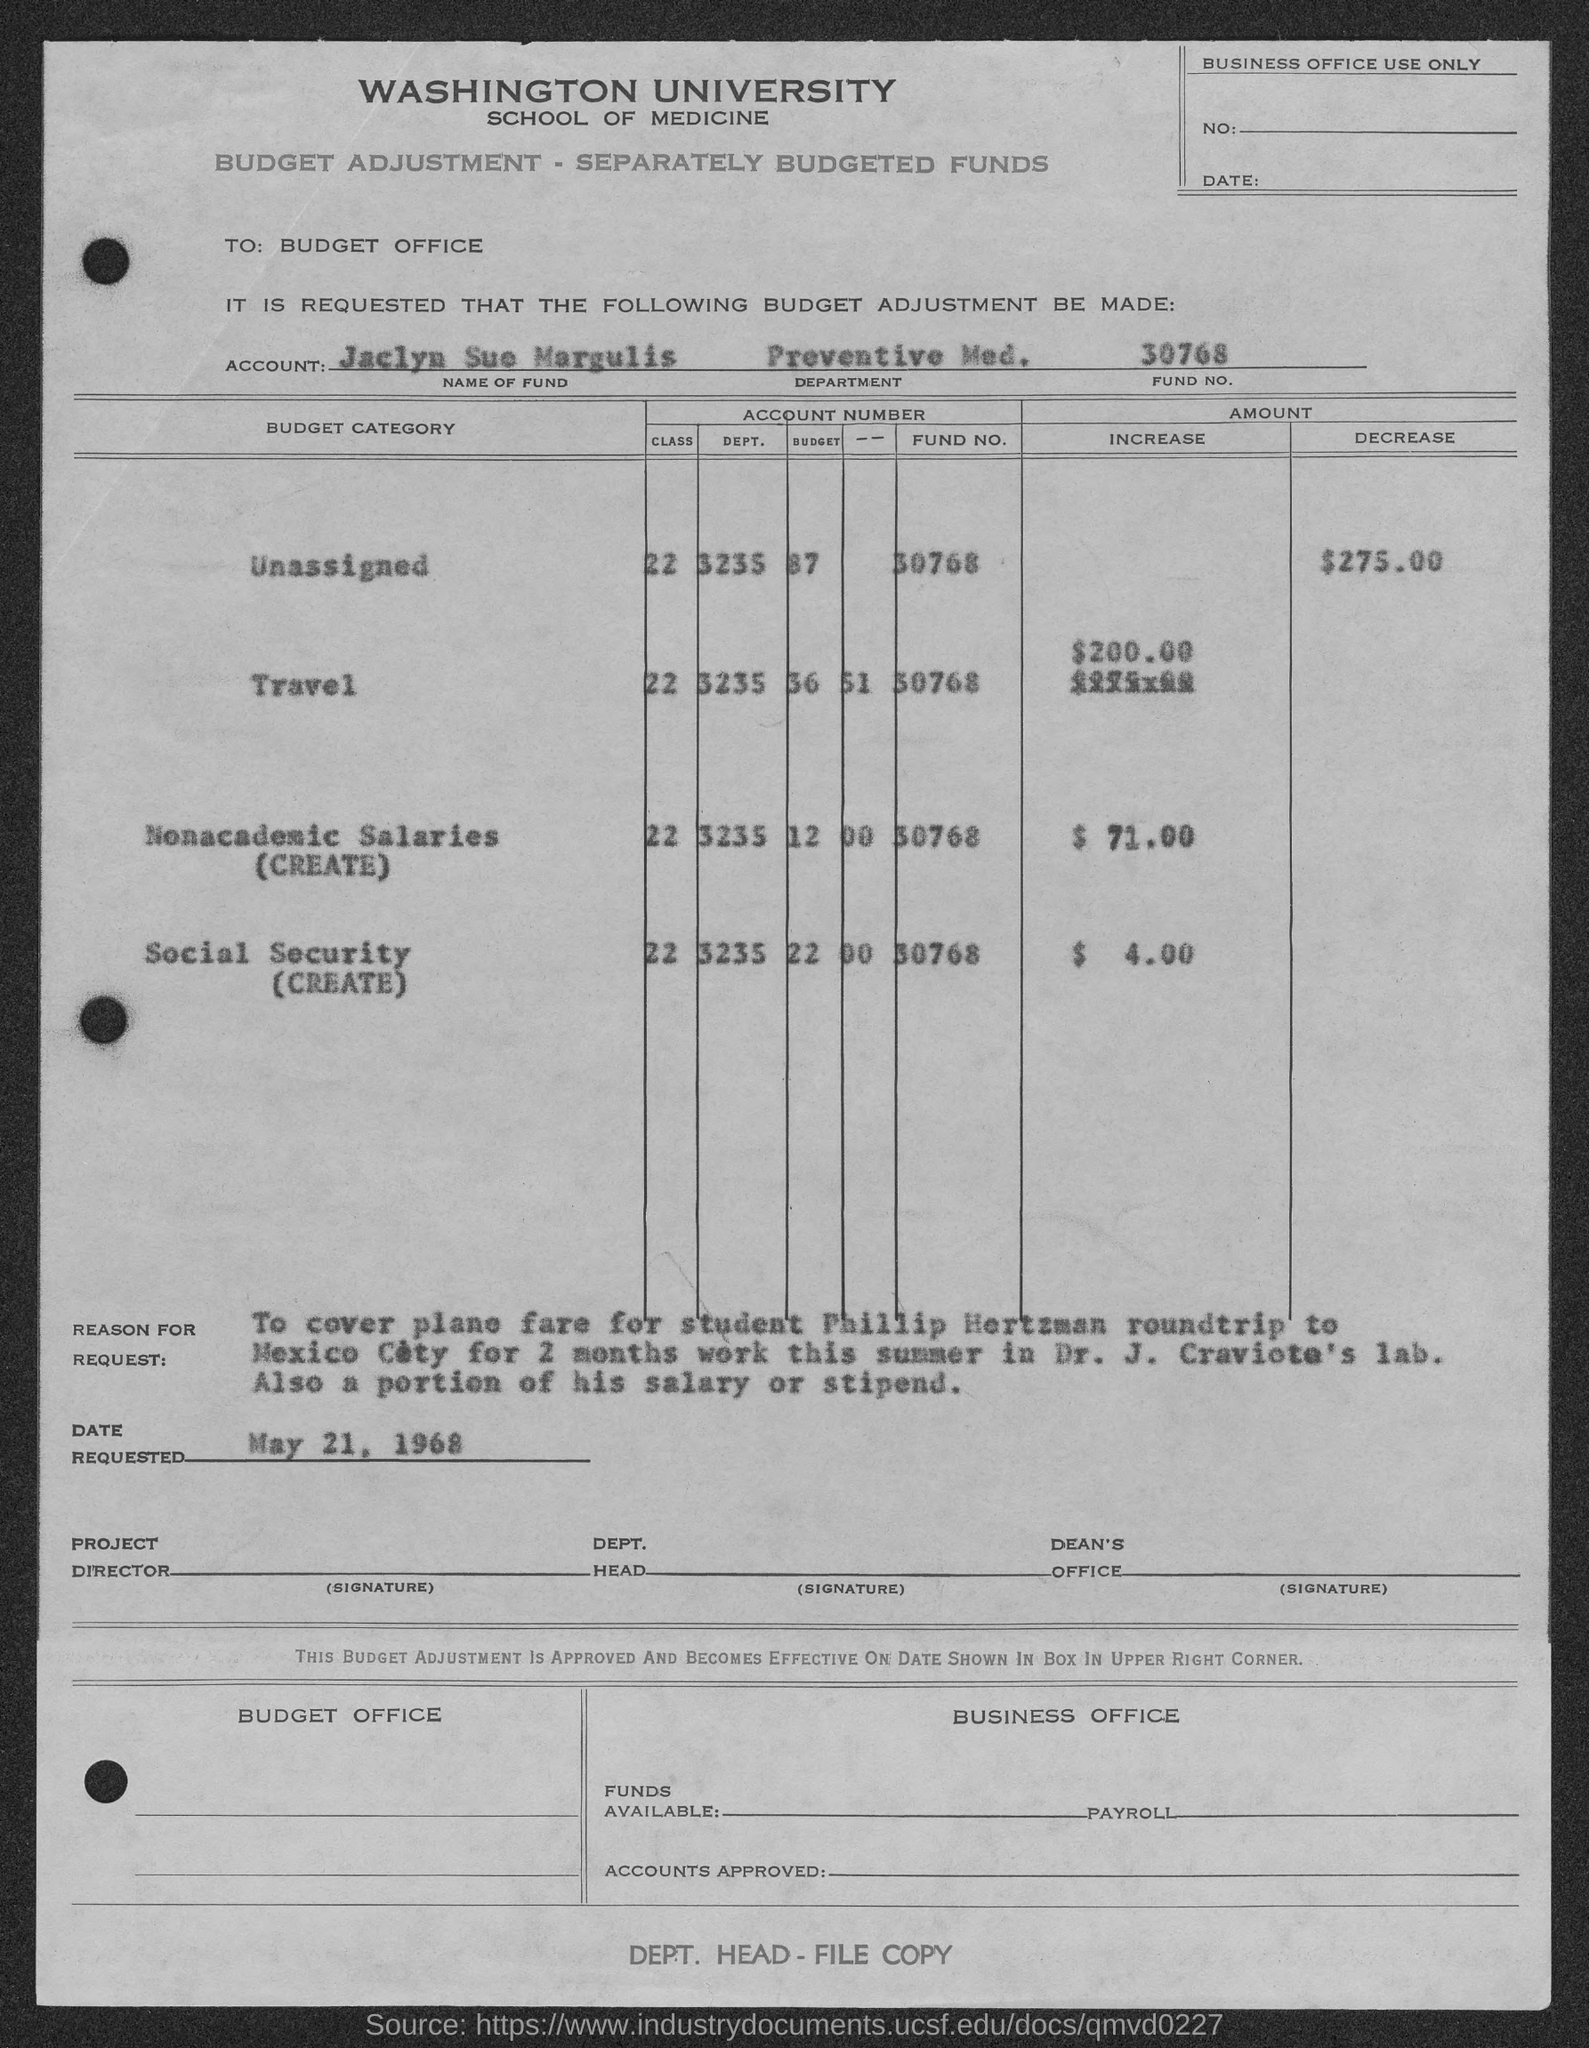What is the name of the university mentioned in the given page ?
Ensure brevity in your answer.  Washington university. What is the date requested as mentioned in the given page ?
Make the answer very short. May 21, 1968. What is the fund no. mentioned in the given page ?
Your response must be concise. 30768. What is the increase amount of the travel budget mentioned in the given page ?
Offer a very short reply. $200.00. What is the decrease amount of the unassigned budget mentioned in the given page ?
Provide a succinct answer. 275. What is the fund no. for travel am mentioned in the given page ?
Give a very brief answer. 30768. What is the increase amount of the nonacademic salaries mentioned in the given page ?
Offer a very short reply. 71.00. What is the increase amount of the social security as mentioned in the given page ?
Make the answer very short. $ 4. What is the dept. no mentioned for the travel budget in the given page ?
Your response must be concise. 3235. 